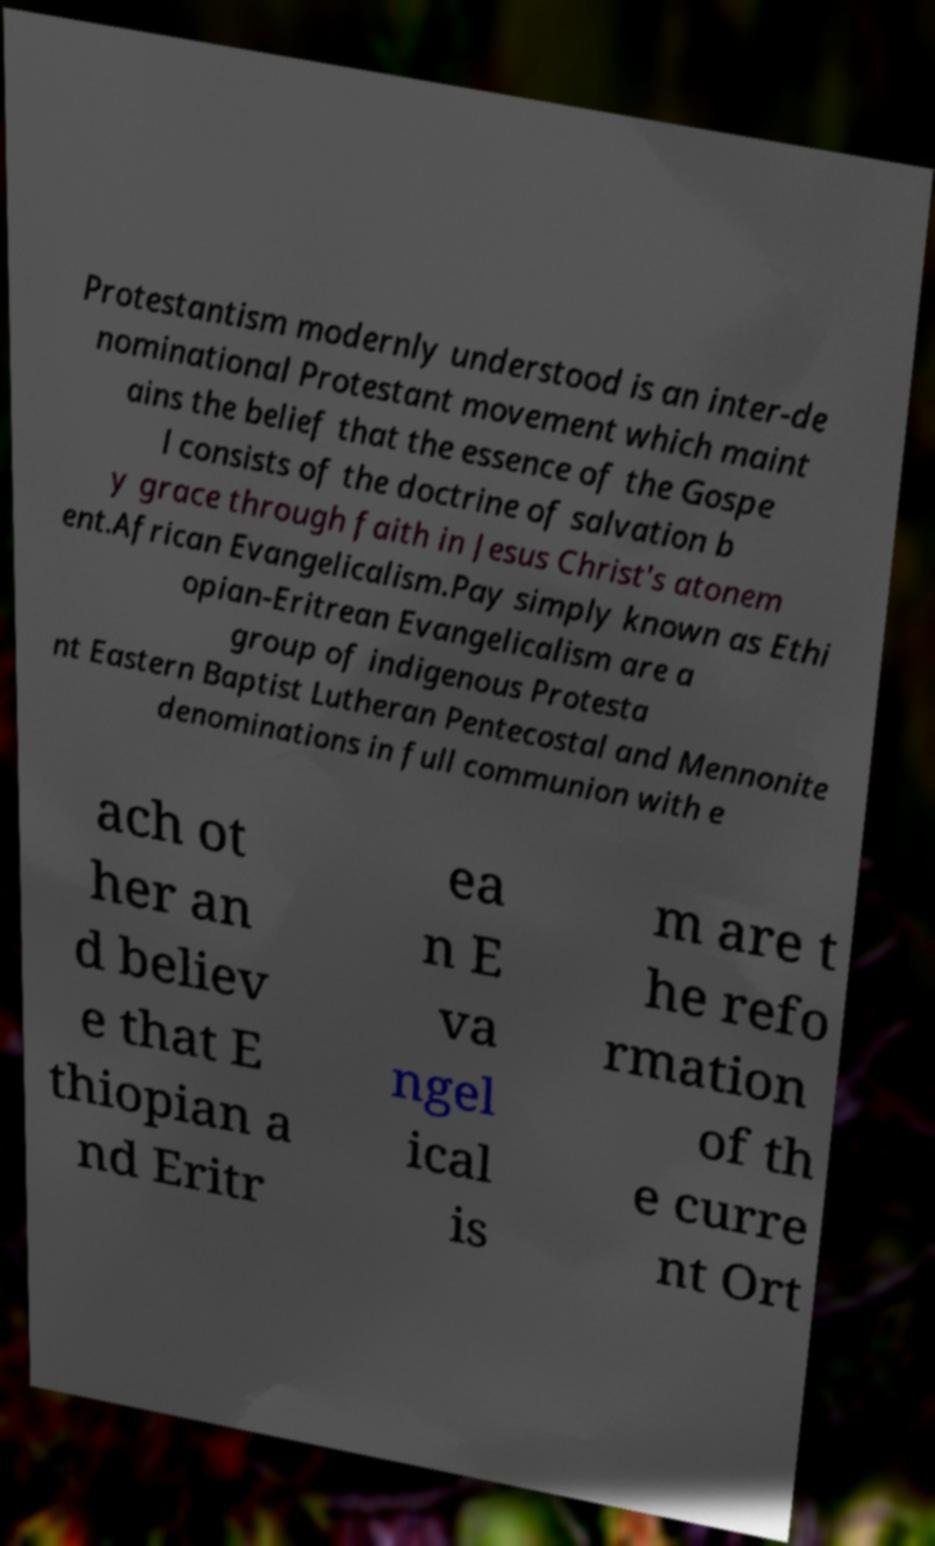Could you extract and type out the text from this image? Protestantism modernly understood is an inter-de nominational Protestant movement which maint ains the belief that the essence of the Gospe l consists of the doctrine of salvation b y grace through faith in Jesus Christ's atonem ent.African Evangelicalism.Pay simply known as Ethi opian-Eritrean Evangelicalism are a group of indigenous Protesta nt Eastern Baptist Lutheran Pentecostal and Mennonite denominations in full communion with e ach ot her an d believ e that E thiopian a nd Eritr ea n E va ngel ical is m are t he refo rmation of th e curre nt Ort 